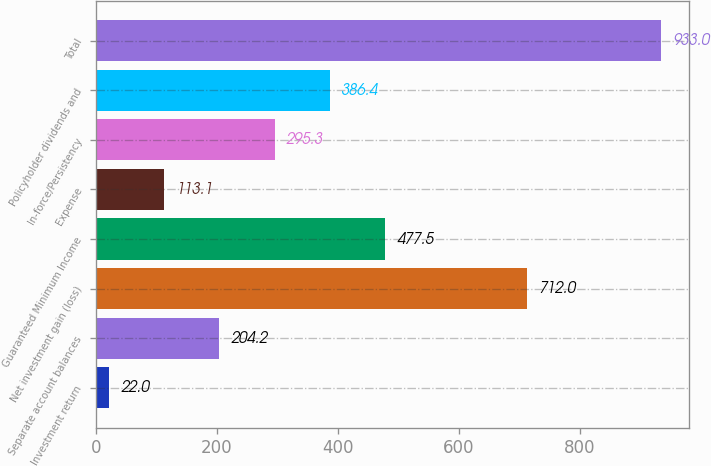<chart> <loc_0><loc_0><loc_500><loc_500><bar_chart><fcel>Investment return<fcel>Separate account balances<fcel>Net investment gain (loss)<fcel>Guaranteed Minimum Income<fcel>Expense<fcel>In-force/Persistency<fcel>Policyholder dividends and<fcel>Total<nl><fcel>22<fcel>204.2<fcel>712<fcel>477.5<fcel>113.1<fcel>295.3<fcel>386.4<fcel>933<nl></chart> 